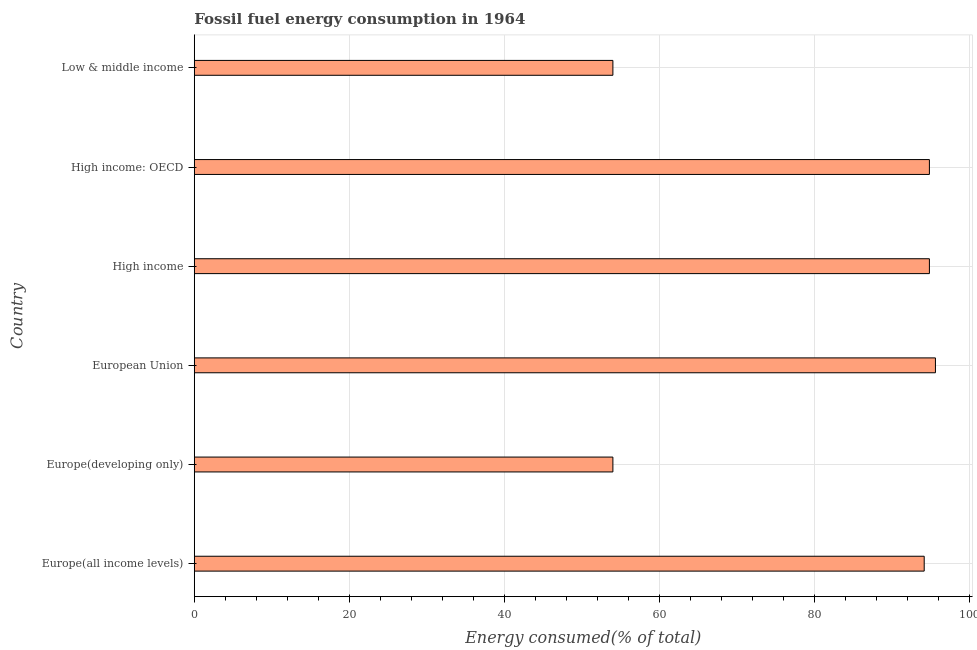Does the graph contain grids?
Provide a succinct answer. Yes. What is the title of the graph?
Your answer should be compact. Fossil fuel energy consumption in 1964. What is the label or title of the X-axis?
Provide a succinct answer. Energy consumed(% of total). What is the label or title of the Y-axis?
Provide a short and direct response. Country. What is the fossil fuel energy consumption in Low & middle income?
Ensure brevity in your answer.  53.97. Across all countries, what is the maximum fossil fuel energy consumption?
Your answer should be very brief. 95.56. Across all countries, what is the minimum fossil fuel energy consumption?
Provide a short and direct response. 53.97. In which country was the fossil fuel energy consumption minimum?
Ensure brevity in your answer.  Europe(developing only). What is the sum of the fossil fuel energy consumption?
Give a very brief answer. 487.19. What is the difference between the fossil fuel energy consumption in Europe(all income levels) and High income?
Keep it short and to the point. -0.67. What is the average fossil fuel energy consumption per country?
Your answer should be compact. 81.2. What is the median fossil fuel energy consumption?
Ensure brevity in your answer.  94.45. What is the ratio of the fossil fuel energy consumption in High income to that in High income: OECD?
Make the answer very short. 1. Is the fossil fuel energy consumption in Europe(all income levels) less than that in High income?
Your answer should be compact. Yes. Is the difference between the fossil fuel energy consumption in High income and Low & middle income greater than the difference between any two countries?
Ensure brevity in your answer.  No. What is the difference between the highest and the second highest fossil fuel energy consumption?
Your response must be concise. 0.78. What is the difference between the highest and the lowest fossil fuel energy consumption?
Make the answer very short. 41.58. In how many countries, is the fossil fuel energy consumption greater than the average fossil fuel energy consumption taken over all countries?
Keep it short and to the point. 4. How many bars are there?
Offer a terse response. 6. How many countries are there in the graph?
Your response must be concise. 6. Are the values on the major ticks of X-axis written in scientific E-notation?
Offer a terse response. No. What is the Energy consumed(% of total) of Europe(all income levels)?
Provide a succinct answer. 94.11. What is the Energy consumed(% of total) in Europe(developing only)?
Ensure brevity in your answer.  53.97. What is the Energy consumed(% of total) in European Union?
Provide a succinct answer. 95.56. What is the Energy consumed(% of total) of High income?
Make the answer very short. 94.78. What is the Energy consumed(% of total) of High income: OECD?
Make the answer very short. 94.78. What is the Energy consumed(% of total) in Low & middle income?
Your answer should be very brief. 53.97. What is the difference between the Energy consumed(% of total) in Europe(all income levels) and Europe(developing only)?
Provide a succinct answer. 40.14. What is the difference between the Energy consumed(% of total) in Europe(all income levels) and European Union?
Offer a terse response. -1.45. What is the difference between the Energy consumed(% of total) in Europe(all income levels) and High income?
Your answer should be very brief. -0.67. What is the difference between the Energy consumed(% of total) in Europe(all income levels) and High income: OECD?
Make the answer very short. -0.67. What is the difference between the Energy consumed(% of total) in Europe(all income levels) and Low & middle income?
Your response must be concise. 40.14. What is the difference between the Energy consumed(% of total) in Europe(developing only) and European Union?
Ensure brevity in your answer.  -41.58. What is the difference between the Energy consumed(% of total) in Europe(developing only) and High income?
Keep it short and to the point. -40.81. What is the difference between the Energy consumed(% of total) in Europe(developing only) and High income: OECD?
Make the answer very short. -40.81. What is the difference between the Energy consumed(% of total) in Europe(developing only) and Low & middle income?
Your answer should be very brief. 0. What is the difference between the Energy consumed(% of total) in European Union and High income?
Provide a short and direct response. 0.78. What is the difference between the Energy consumed(% of total) in European Union and High income: OECD?
Your answer should be very brief. 0.78. What is the difference between the Energy consumed(% of total) in European Union and Low & middle income?
Your response must be concise. 41.58. What is the difference between the Energy consumed(% of total) in High income and High income: OECD?
Your answer should be compact. 0. What is the difference between the Energy consumed(% of total) in High income and Low & middle income?
Your answer should be compact. 40.81. What is the difference between the Energy consumed(% of total) in High income: OECD and Low & middle income?
Keep it short and to the point. 40.81. What is the ratio of the Energy consumed(% of total) in Europe(all income levels) to that in Europe(developing only)?
Your answer should be compact. 1.74. What is the ratio of the Energy consumed(% of total) in Europe(all income levels) to that in Low & middle income?
Provide a short and direct response. 1.74. What is the ratio of the Energy consumed(% of total) in Europe(developing only) to that in European Union?
Provide a succinct answer. 0.56. What is the ratio of the Energy consumed(% of total) in Europe(developing only) to that in High income?
Offer a very short reply. 0.57. What is the ratio of the Energy consumed(% of total) in Europe(developing only) to that in High income: OECD?
Your response must be concise. 0.57. What is the ratio of the Energy consumed(% of total) in Europe(developing only) to that in Low & middle income?
Your response must be concise. 1. What is the ratio of the Energy consumed(% of total) in European Union to that in High income?
Keep it short and to the point. 1.01. What is the ratio of the Energy consumed(% of total) in European Union to that in High income: OECD?
Ensure brevity in your answer.  1.01. What is the ratio of the Energy consumed(% of total) in European Union to that in Low & middle income?
Your response must be concise. 1.77. What is the ratio of the Energy consumed(% of total) in High income to that in Low & middle income?
Provide a succinct answer. 1.76. What is the ratio of the Energy consumed(% of total) in High income: OECD to that in Low & middle income?
Your answer should be compact. 1.76. 